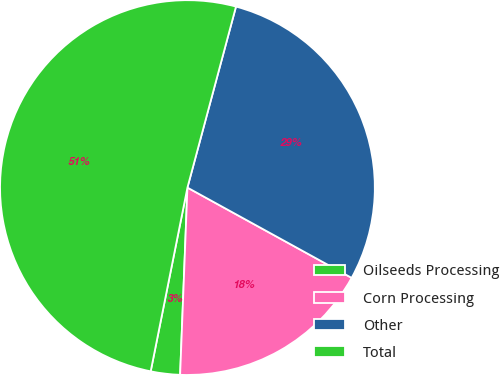Convert chart to OTSL. <chart><loc_0><loc_0><loc_500><loc_500><pie_chart><fcel>Oilseeds Processing<fcel>Corn Processing<fcel>Other<fcel>Total<nl><fcel>2.52%<fcel>17.62%<fcel>28.83%<fcel>51.03%<nl></chart> 